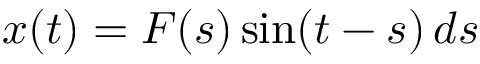<formula> <loc_0><loc_0><loc_500><loc_500>x ( t ) = F ( s ) \sin ( t - s ) \, d s</formula> 